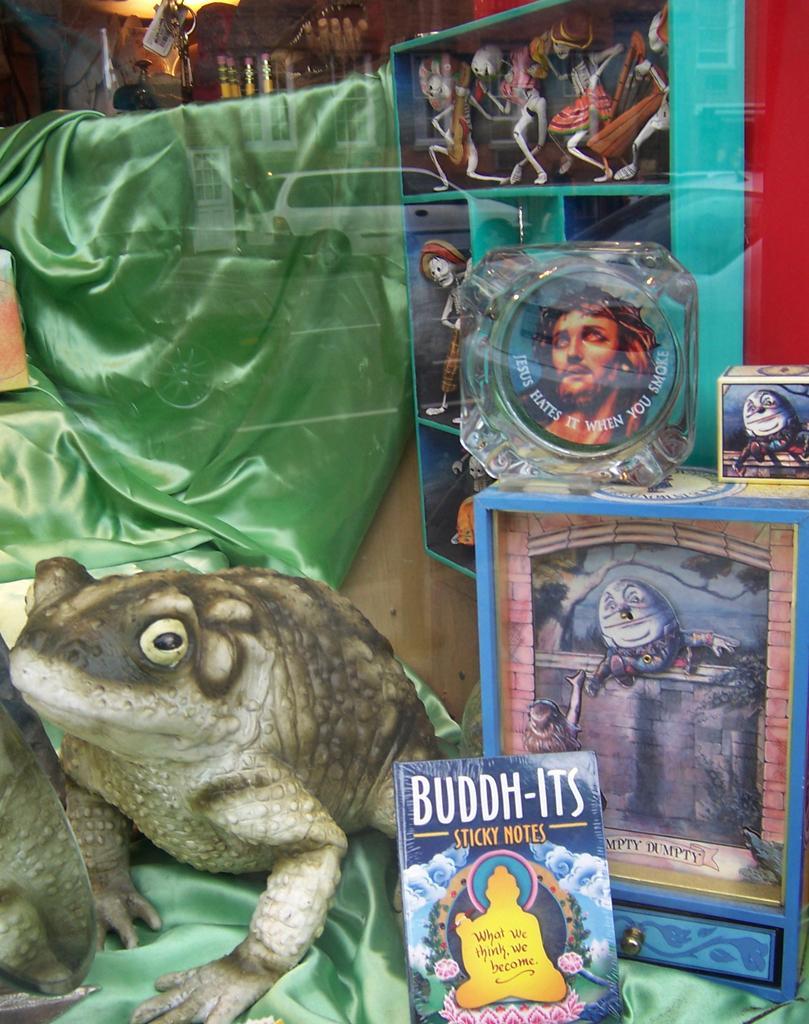Describe this image in one or two sentences. In this image, we can see glass. Through the glass, we can see book, some objects, photo frames, toy, cloth. On the glass we can see some reflections. Here there is a vehicle, door, building with glass windows. 